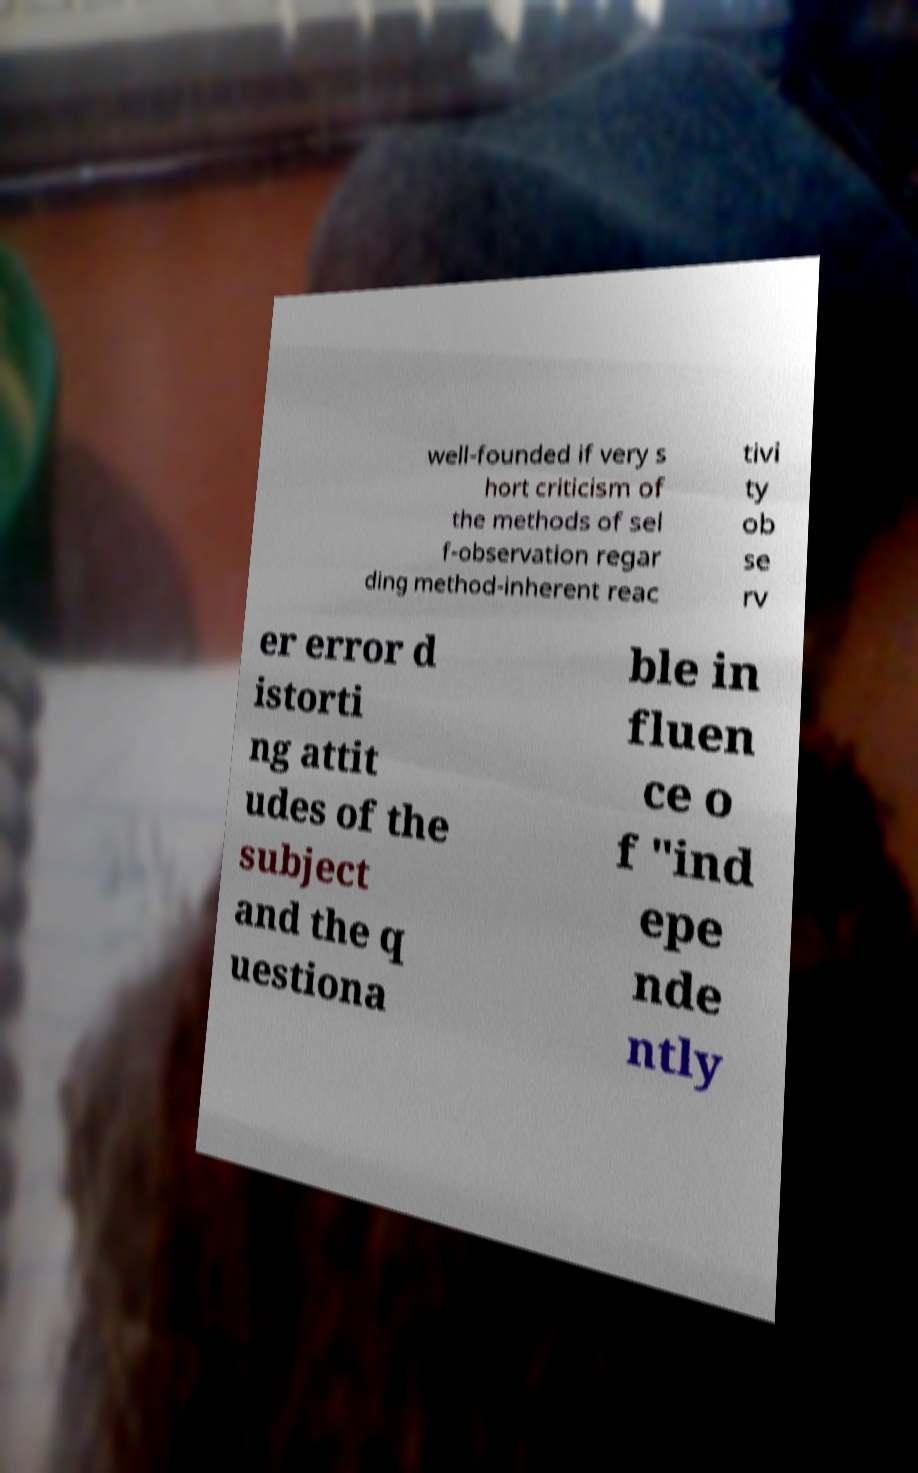Please identify and transcribe the text found in this image. well-founded if very s hort criticism of the methods of sel f-observation regar ding method-inherent reac tivi ty ob se rv er error d istorti ng attit udes of the subject and the q uestiona ble in fluen ce o f "ind epe nde ntly 